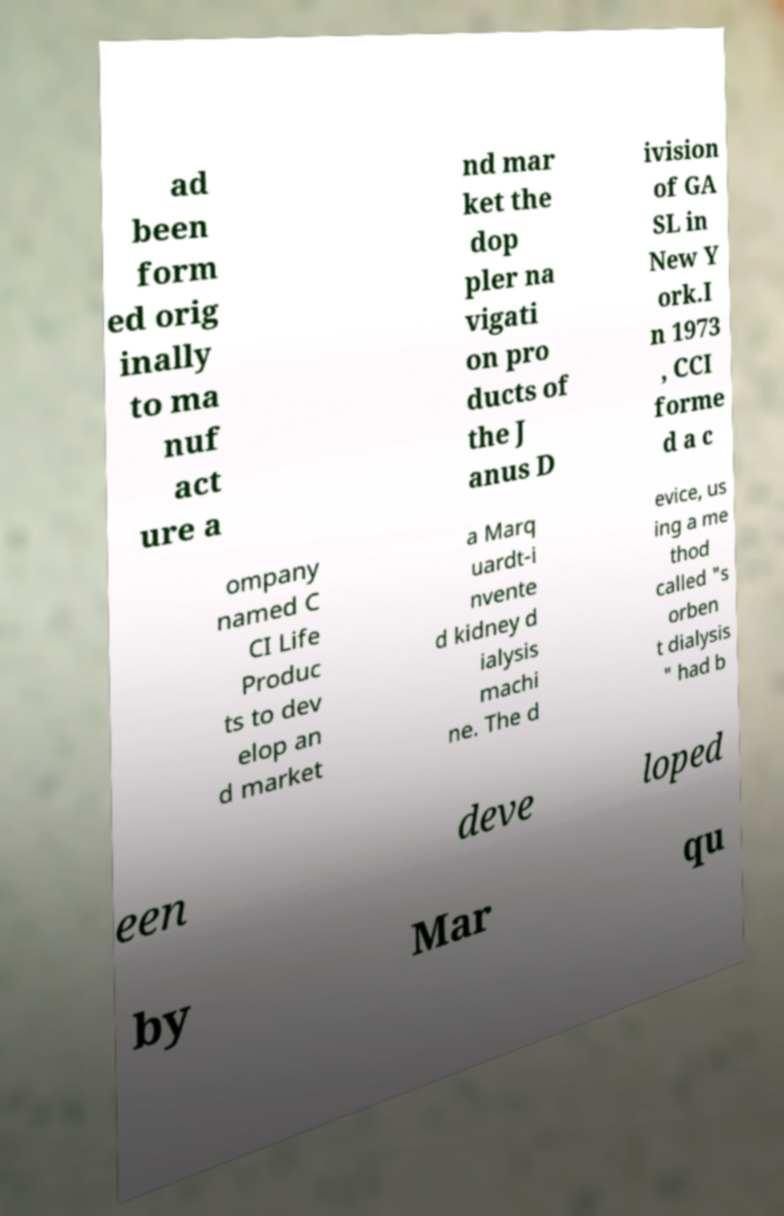I need the written content from this picture converted into text. Can you do that? ad been form ed orig inally to ma nuf act ure a nd mar ket the dop pler na vigati on pro ducts of the J anus D ivision of GA SL in New Y ork.I n 1973 , CCI forme d a c ompany named C CI Life Produc ts to dev elop an d market a Marq uardt-i nvente d kidney d ialysis machi ne. The d evice, us ing a me thod called "s orben t dialysis " had b een deve loped by Mar qu 